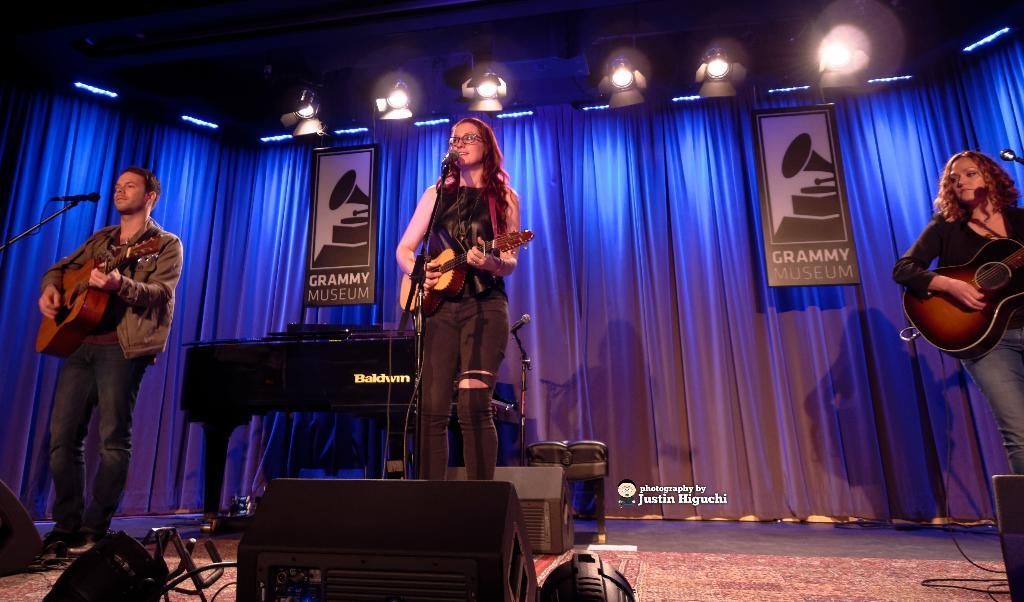What type of window treatment is visible in the image? There are curtains in the image. Who or what can be seen in the image? There are people in the image. What are the people holding in the image? The people are holding guitars. What objects are in front of the people in the image? There are microphones in front of the people. Can you tell me how many owls are sitting on the guitars in the image? There are no owls present in the image; the people are holding guitars. What type of poison is being used by the people in the image? There is no mention of poison in the image; the people are holding guitars and there are microphones in front of them. 